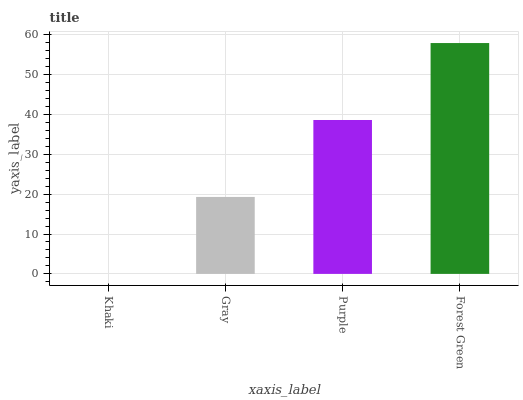Is Khaki the minimum?
Answer yes or no. Yes. Is Forest Green the maximum?
Answer yes or no. Yes. Is Gray the minimum?
Answer yes or no. No. Is Gray the maximum?
Answer yes or no. No. Is Gray greater than Khaki?
Answer yes or no. Yes. Is Khaki less than Gray?
Answer yes or no. Yes. Is Khaki greater than Gray?
Answer yes or no. No. Is Gray less than Khaki?
Answer yes or no. No. Is Purple the high median?
Answer yes or no. Yes. Is Gray the low median?
Answer yes or no. Yes. Is Forest Green the high median?
Answer yes or no. No. Is Purple the low median?
Answer yes or no. No. 